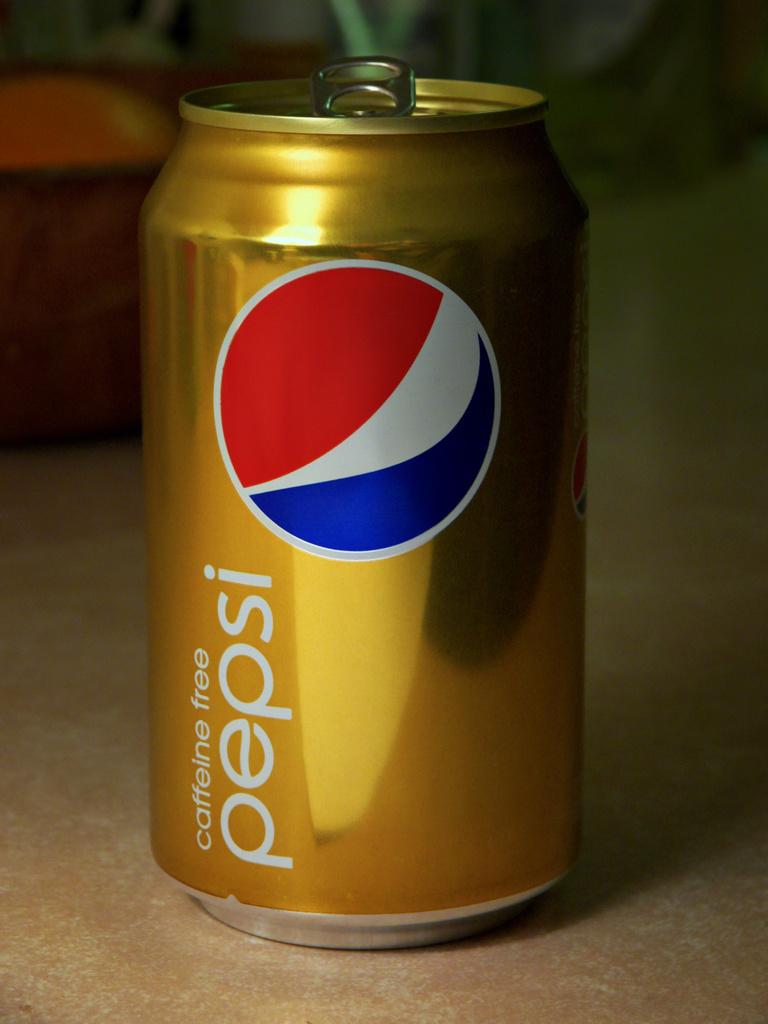What brand of caffeine free cola is this?
Provide a short and direct response. Pepsi. 